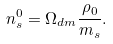Convert formula to latex. <formula><loc_0><loc_0><loc_500><loc_500>n _ { s } ^ { 0 } = \Omega _ { d m } \frac { \rho _ { 0 } } { m _ { s } } .</formula> 